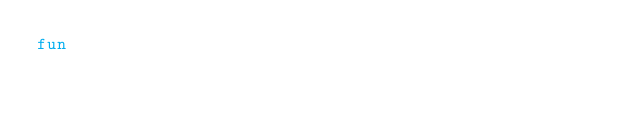Convert code to text. <code><loc_0><loc_0><loc_500><loc_500><_Kotlin_>fun</code> 